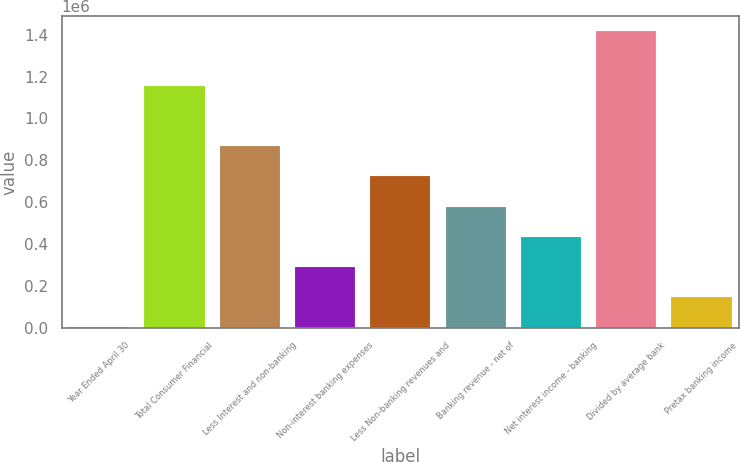Convert chart. <chart><loc_0><loc_0><loc_500><loc_500><bar_chart><fcel>Year Ended April 30<fcel>Total Consumer Financial<fcel>Less Interest and non-banking<fcel>Non-interest banking expenses<fcel>Less Non-banking revenues and<fcel>Banking revenue - net of<fcel>Net interest income - banking<fcel>Divided by average bank<fcel>Pretax banking income<nl><fcel>2008<fcel>1.1547e+06<fcel>866524<fcel>290180<fcel>722438<fcel>578352<fcel>434266<fcel>1.41737e+06<fcel>146094<nl></chart> 